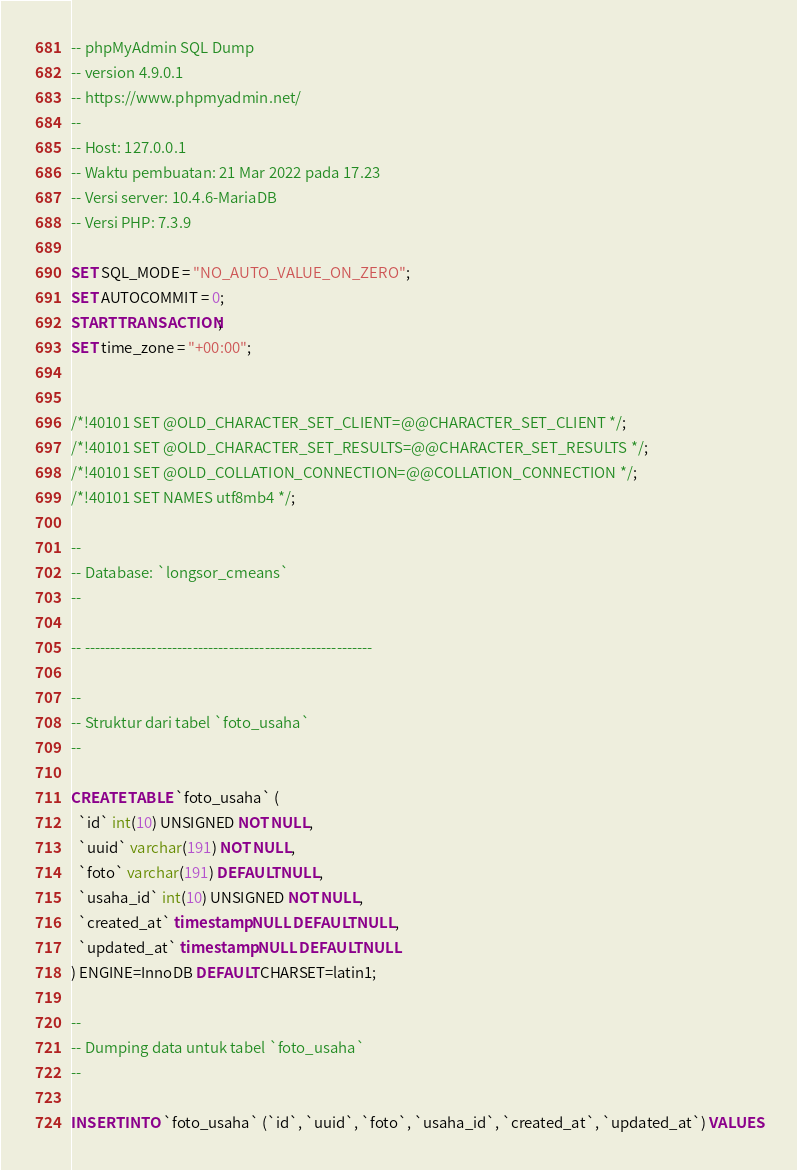Convert code to text. <code><loc_0><loc_0><loc_500><loc_500><_SQL_>-- phpMyAdmin SQL Dump
-- version 4.9.0.1
-- https://www.phpmyadmin.net/
--
-- Host: 127.0.0.1
-- Waktu pembuatan: 21 Mar 2022 pada 17.23
-- Versi server: 10.4.6-MariaDB
-- Versi PHP: 7.3.9

SET SQL_MODE = "NO_AUTO_VALUE_ON_ZERO";
SET AUTOCOMMIT = 0;
START TRANSACTION;
SET time_zone = "+00:00";


/*!40101 SET @OLD_CHARACTER_SET_CLIENT=@@CHARACTER_SET_CLIENT */;
/*!40101 SET @OLD_CHARACTER_SET_RESULTS=@@CHARACTER_SET_RESULTS */;
/*!40101 SET @OLD_COLLATION_CONNECTION=@@COLLATION_CONNECTION */;
/*!40101 SET NAMES utf8mb4 */;

--
-- Database: `longsor_cmeans`
--

-- --------------------------------------------------------

--
-- Struktur dari tabel `foto_usaha`
--

CREATE TABLE `foto_usaha` (
  `id` int(10) UNSIGNED NOT NULL,
  `uuid` varchar(191) NOT NULL,
  `foto` varchar(191) DEFAULT NULL,
  `usaha_id` int(10) UNSIGNED NOT NULL,
  `created_at` timestamp NULL DEFAULT NULL,
  `updated_at` timestamp NULL DEFAULT NULL
) ENGINE=InnoDB DEFAULT CHARSET=latin1;

--
-- Dumping data untuk tabel `foto_usaha`
--

INSERT INTO `foto_usaha` (`id`, `uuid`, `foto`, `usaha_id`, `created_at`, `updated_at`) VALUES</code> 